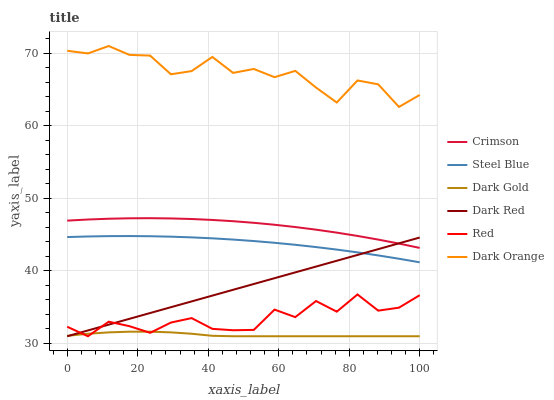Does Dark Gold have the minimum area under the curve?
Answer yes or no. Yes. Does Dark Orange have the maximum area under the curve?
Answer yes or no. Yes. Does Dark Red have the minimum area under the curve?
Answer yes or no. No. Does Dark Red have the maximum area under the curve?
Answer yes or no. No. Is Dark Red the smoothest?
Answer yes or no. Yes. Is Dark Orange the roughest?
Answer yes or no. Yes. Is Dark Gold the smoothest?
Answer yes or no. No. Is Dark Gold the roughest?
Answer yes or no. No. Does Steel Blue have the lowest value?
Answer yes or no. No. Does Dark Orange have the highest value?
Answer yes or no. Yes. Does Dark Red have the highest value?
Answer yes or no. No. Is Dark Gold less than Dark Orange?
Answer yes or no. Yes. Is Dark Orange greater than Red?
Answer yes or no. Yes. Does Dark Gold intersect Dark Orange?
Answer yes or no. No. 